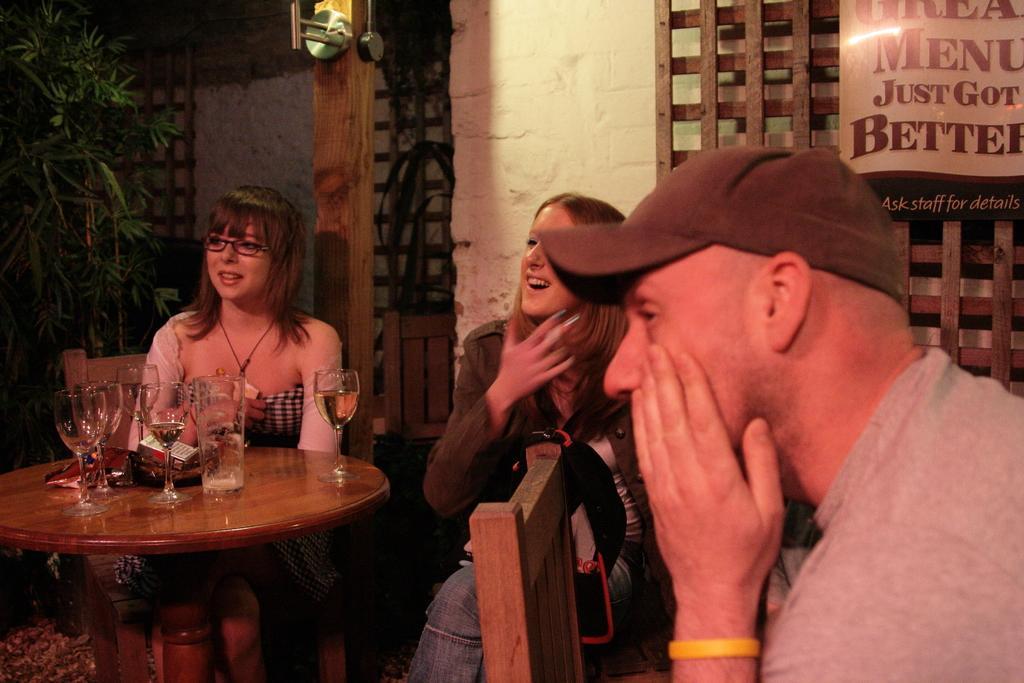How would you summarize this image in a sentence or two? In the image we can see there are three people sitting on a chair in front of them there is a table and wine glasses are kept on it. Beside there is a tree. 